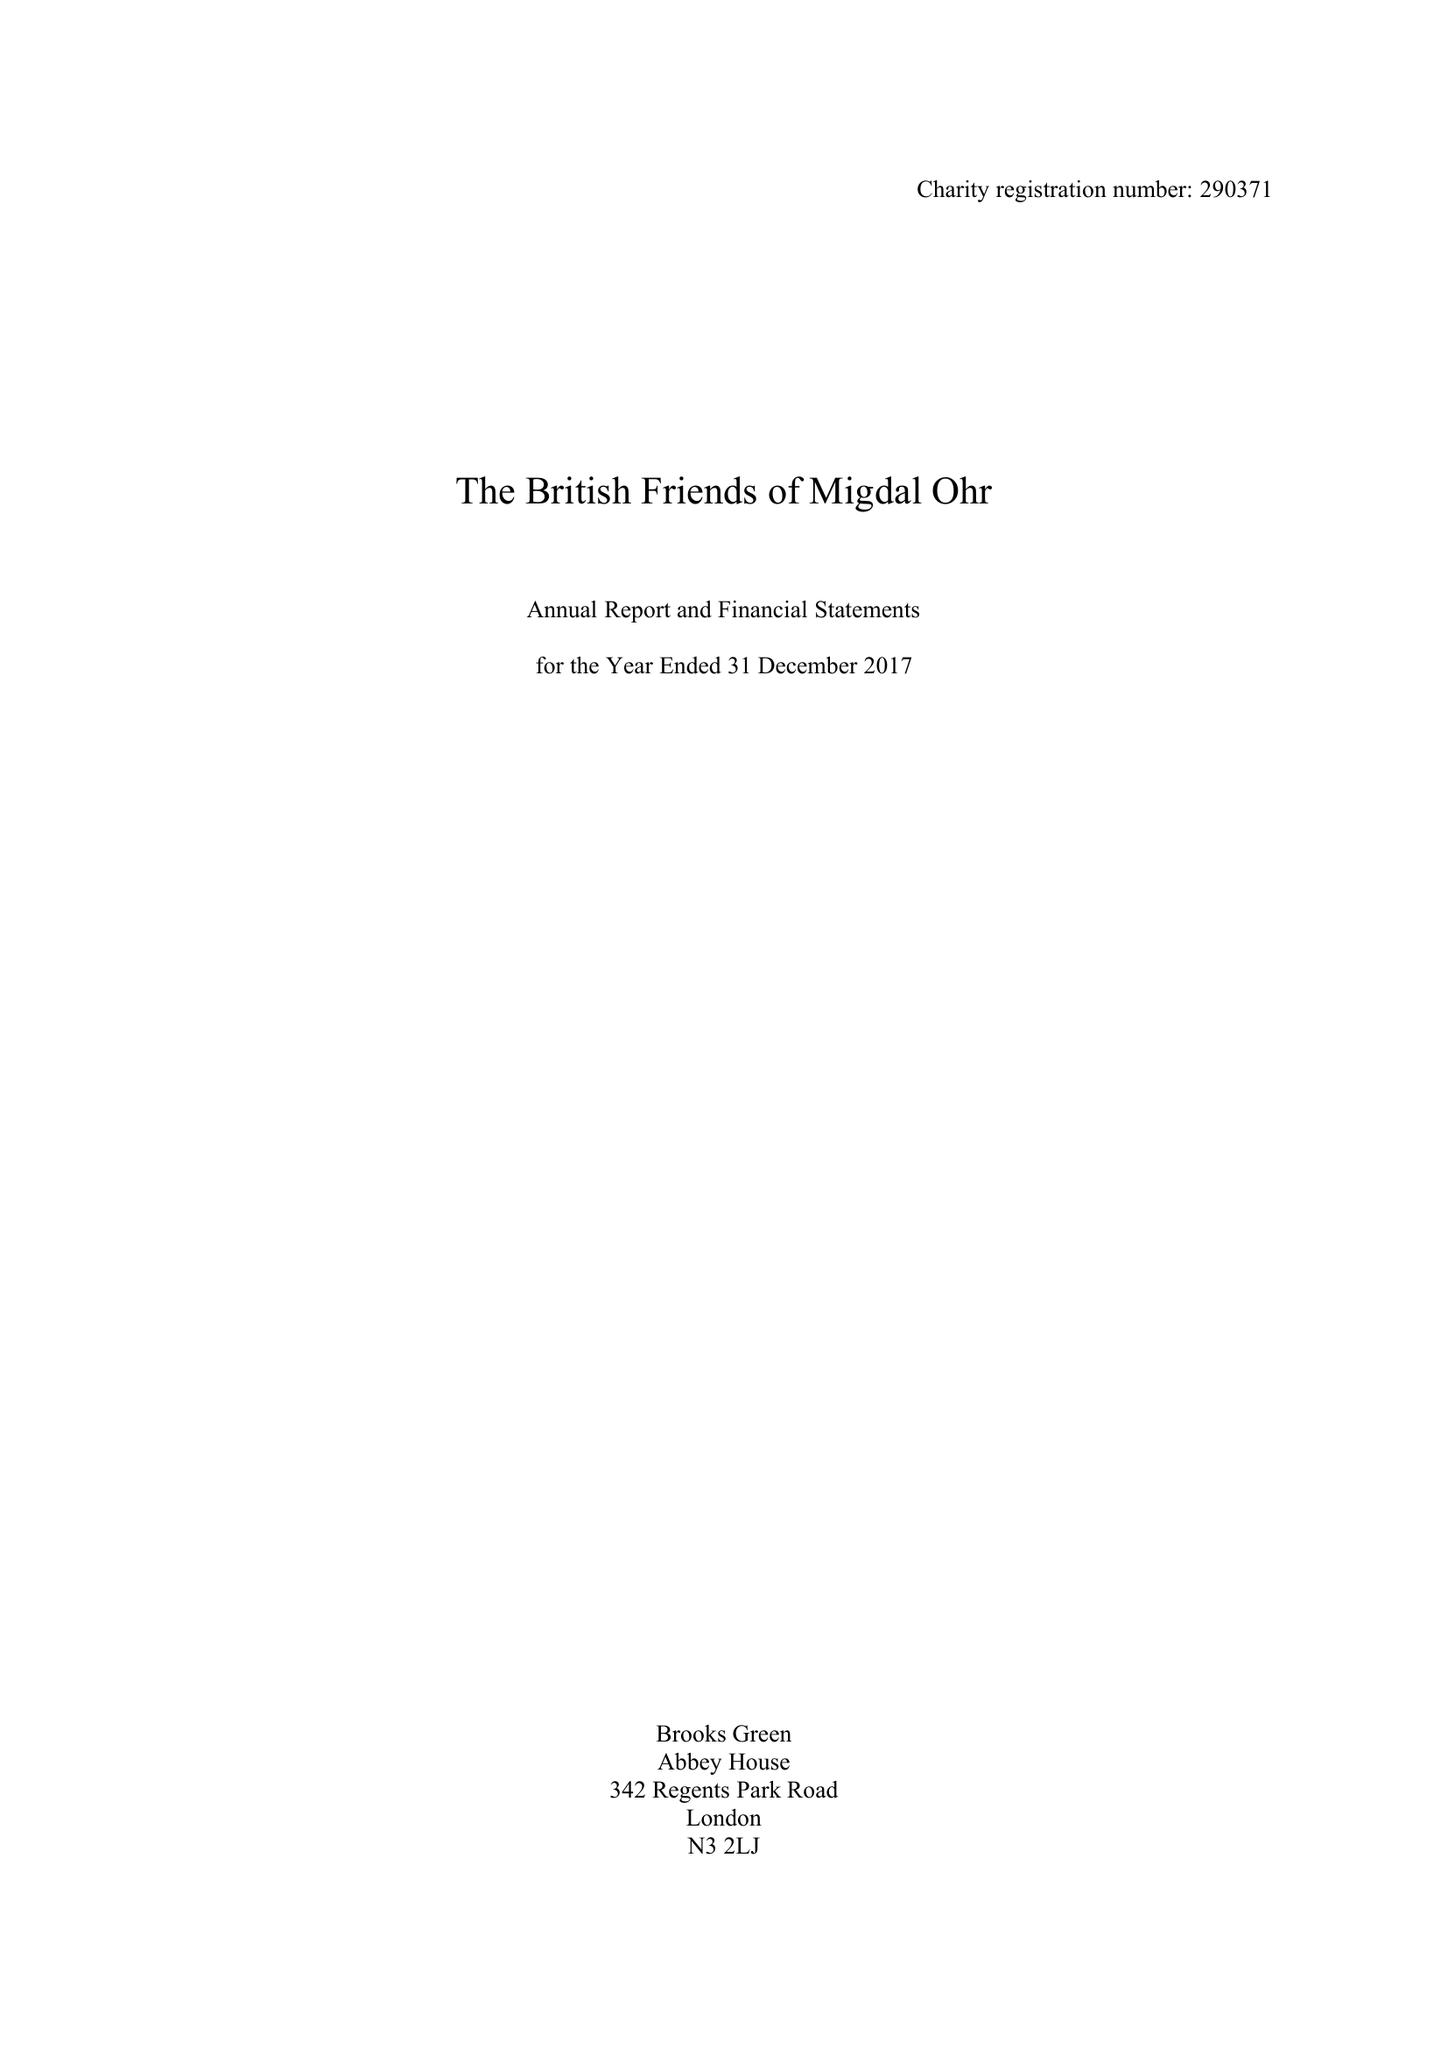What is the value for the address__post_town?
Answer the question using a single word or phrase. LONDON 